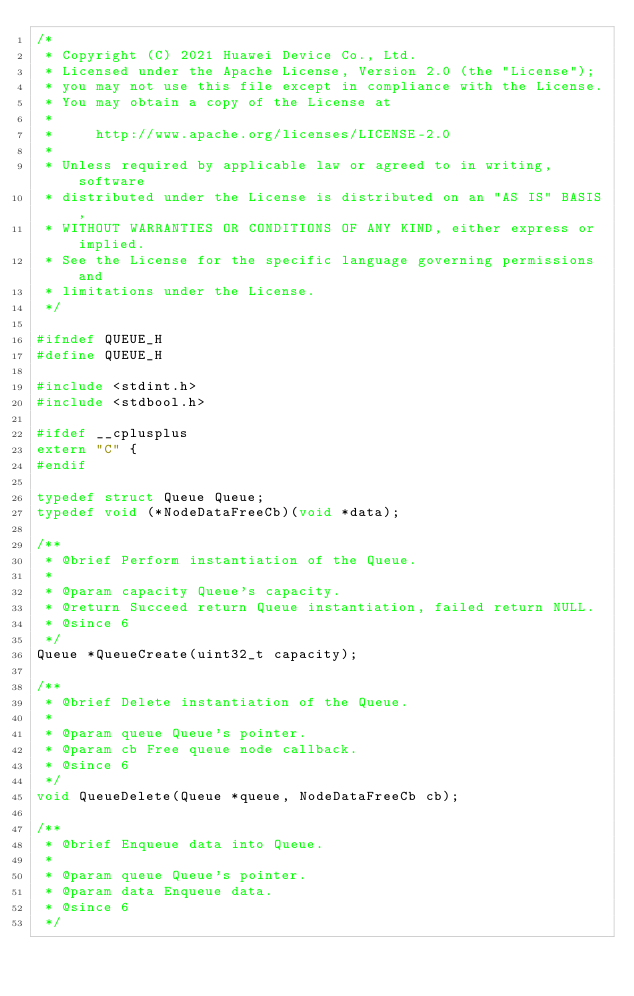<code> <loc_0><loc_0><loc_500><loc_500><_C_>/*
 * Copyright (C) 2021 Huawei Device Co., Ltd.
 * Licensed under the Apache License, Version 2.0 (the "License");
 * you may not use this file except in compliance with the License.
 * You may obtain a copy of the License at
 *
 *     http://www.apache.org/licenses/LICENSE-2.0
 *
 * Unless required by applicable law or agreed to in writing, software
 * distributed under the License is distributed on an "AS IS" BASIS,
 * WITHOUT WARRANTIES OR CONDITIONS OF ANY KIND, either express or implied.
 * See the License for the specific language governing permissions and
 * limitations under the License.
 */

#ifndef QUEUE_H
#define QUEUE_H

#include <stdint.h>
#include <stdbool.h>

#ifdef __cplusplus
extern "C" {
#endif

typedef struct Queue Queue;
typedef void (*NodeDataFreeCb)(void *data);

/**
 * @brief Perform instantiation of the Queue.
 *
 * @param capacity Queue's capacity.
 * @return Succeed return Queue instantiation, failed return NULL.
 * @since 6
 */
Queue *QueueCreate(uint32_t capacity);

/**
 * @brief Delete instantiation of the Queue.
 *
 * @param queue Queue's pointer.
 * @param cb Free queue node callback.
 * @since 6
 */
void QueueDelete(Queue *queue, NodeDataFreeCb cb);

/**
 * @brief Enqueue data into Queue.
 *
 * @param queue Queue's pointer.
 * @param data Enqueue data.
 * @since 6
 */</code> 